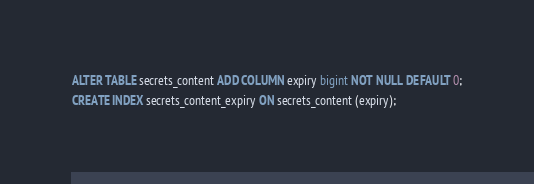Convert code to text. <code><loc_0><loc_0><loc_500><loc_500><_SQL_>ALTER TABLE secrets_content ADD COLUMN expiry bigint NOT NULL DEFAULT 0;
CREATE INDEX secrets_content_expiry ON secrets_content (expiry);
</code> 